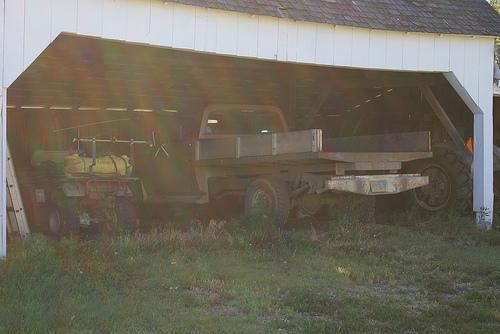How many garages are pictured?
Give a very brief answer. 1. 